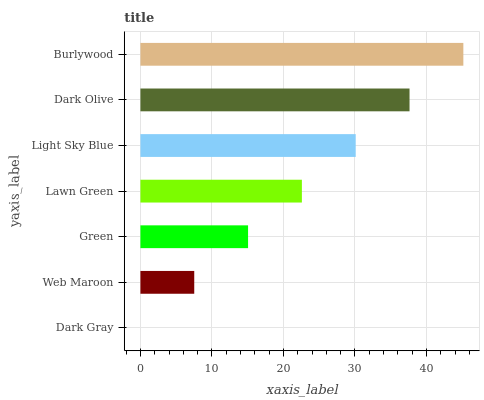Is Dark Gray the minimum?
Answer yes or no. Yes. Is Burlywood the maximum?
Answer yes or no. Yes. Is Web Maroon the minimum?
Answer yes or no. No. Is Web Maroon the maximum?
Answer yes or no. No. Is Web Maroon greater than Dark Gray?
Answer yes or no. Yes. Is Dark Gray less than Web Maroon?
Answer yes or no. Yes. Is Dark Gray greater than Web Maroon?
Answer yes or no. No. Is Web Maroon less than Dark Gray?
Answer yes or no. No. Is Lawn Green the high median?
Answer yes or no. Yes. Is Lawn Green the low median?
Answer yes or no. Yes. Is Light Sky Blue the high median?
Answer yes or no. No. Is Dark Gray the low median?
Answer yes or no. No. 